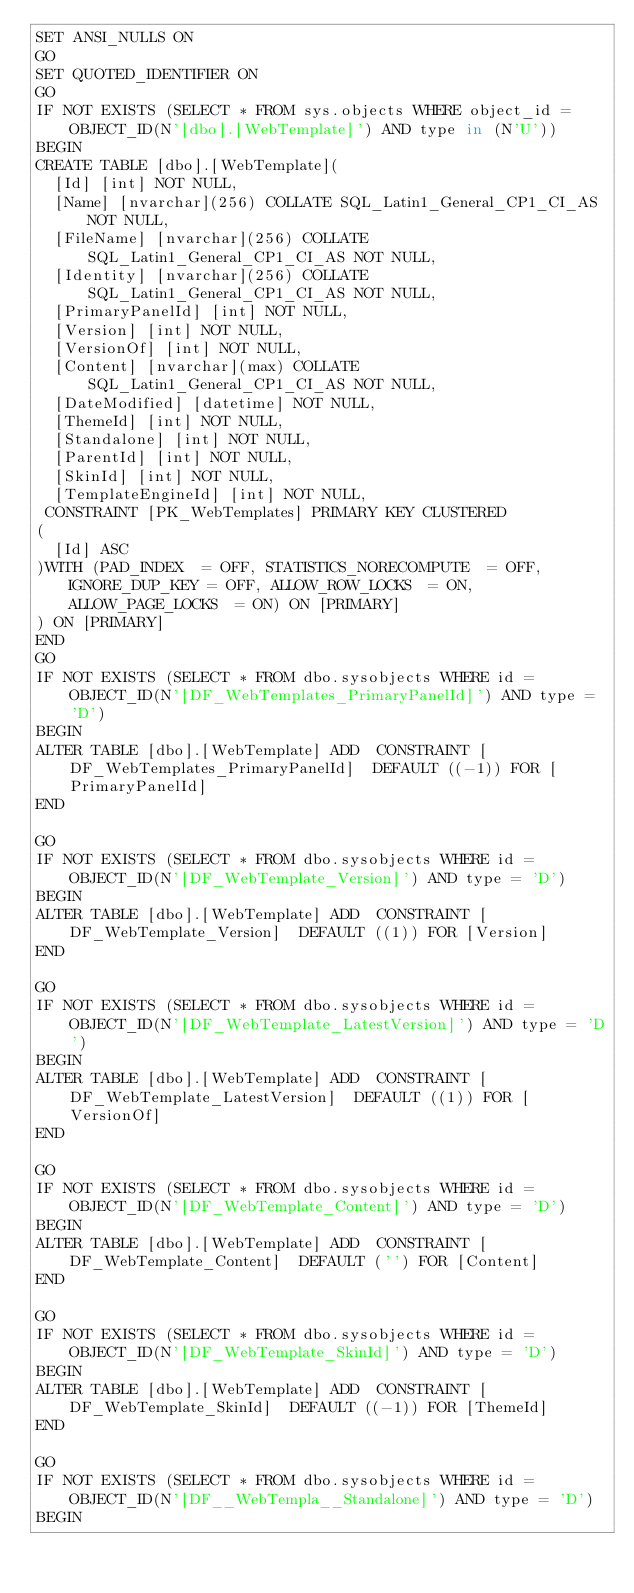<code> <loc_0><loc_0><loc_500><loc_500><_SQL_>SET ANSI_NULLS ON
GO
SET QUOTED_IDENTIFIER ON
GO
IF NOT EXISTS (SELECT * FROM sys.objects WHERE object_id = OBJECT_ID(N'[dbo].[WebTemplate]') AND type in (N'U'))
BEGIN
CREATE TABLE [dbo].[WebTemplate](
	[Id] [int] NOT NULL,
	[Name] [nvarchar](256) COLLATE SQL_Latin1_General_CP1_CI_AS NOT NULL,
	[FileName] [nvarchar](256) COLLATE SQL_Latin1_General_CP1_CI_AS NOT NULL,
	[Identity] [nvarchar](256) COLLATE SQL_Latin1_General_CP1_CI_AS NOT NULL,
	[PrimaryPanelId] [int] NOT NULL,
	[Version] [int] NOT NULL,
	[VersionOf] [int] NOT NULL,
	[Content] [nvarchar](max) COLLATE SQL_Latin1_General_CP1_CI_AS NOT NULL,
	[DateModified] [datetime] NOT NULL,
	[ThemeId] [int] NOT NULL,
	[Standalone] [int] NOT NULL,
	[ParentId] [int] NOT NULL,
	[SkinId] [int] NOT NULL,
	[TemplateEngineId] [int] NOT NULL,
 CONSTRAINT [PK_WebTemplates] PRIMARY KEY CLUSTERED 
(
	[Id] ASC
)WITH (PAD_INDEX  = OFF, STATISTICS_NORECOMPUTE  = OFF, IGNORE_DUP_KEY = OFF, ALLOW_ROW_LOCKS  = ON, ALLOW_PAGE_LOCKS  = ON) ON [PRIMARY]
) ON [PRIMARY]
END
GO
IF NOT EXISTS (SELECT * FROM dbo.sysobjects WHERE id = OBJECT_ID(N'[DF_WebTemplates_PrimaryPanelId]') AND type = 'D')
BEGIN
ALTER TABLE [dbo].[WebTemplate] ADD  CONSTRAINT [DF_WebTemplates_PrimaryPanelId]  DEFAULT ((-1)) FOR [PrimaryPanelId]
END

GO
IF NOT EXISTS (SELECT * FROM dbo.sysobjects WHERE id = OBJECT_ID(N'[DF_WebTemplate_Version]') AND type = 'D')
BEGIN
ALTER TABLE [dbo].[WebTemplate] ADD  CONSTRAINT [DF_WebTemplate_Version]  DEFAULT ((1)) FOR [Version]
END

GO
IF NOT EXISTS (SELECT * FROM dbo.sysobjects WHERE id = OBJECT_ID(N'[DF_WebTemplate_LatestVersion]') AND type = 'D')
BEGIN
ALTER TABLE [dbo].[WebTemplate] ADD  CONSTRAINT [DF_WebTemplate_LatestVersion]  DEFAULT ((1)) FOR [VersionOf]
END

GO
IF NOT EXISTS (SELECT * FROM dbo.sysobjects WHERE id = OBJECT_ID(N'[DF_WebTemplate_Content]') AND type = 'D')
BEGIN
ALTER TABLE [dbo].[WebTemplate] ADD  CONSTRAINT [DF_WebTemplate_Content]  DEFAULT ('') FOR [Content]
END

GO
IF NOT EXISTS (SELECT * FROM dbo.sysobjects WHERE id = OBJECT_ID(N'[DF_WebTemplate_SkinId]') AND type = 'D')
BEGIN
ALTER TABLE [dbo].[WebTemplate] ADD  CONSTRAINT [DF_WebTemplate_SkinId]  DEFAULT ((-1)) FOR [ThemeId]
END

GO
IF NOT EXISTS (SELECT * FROM dbo.sysobjects WHERE id = OBJECT_ID(N'[DF__WebTempla__Standalone]') AND type = 'D')
BEGIN</code> 